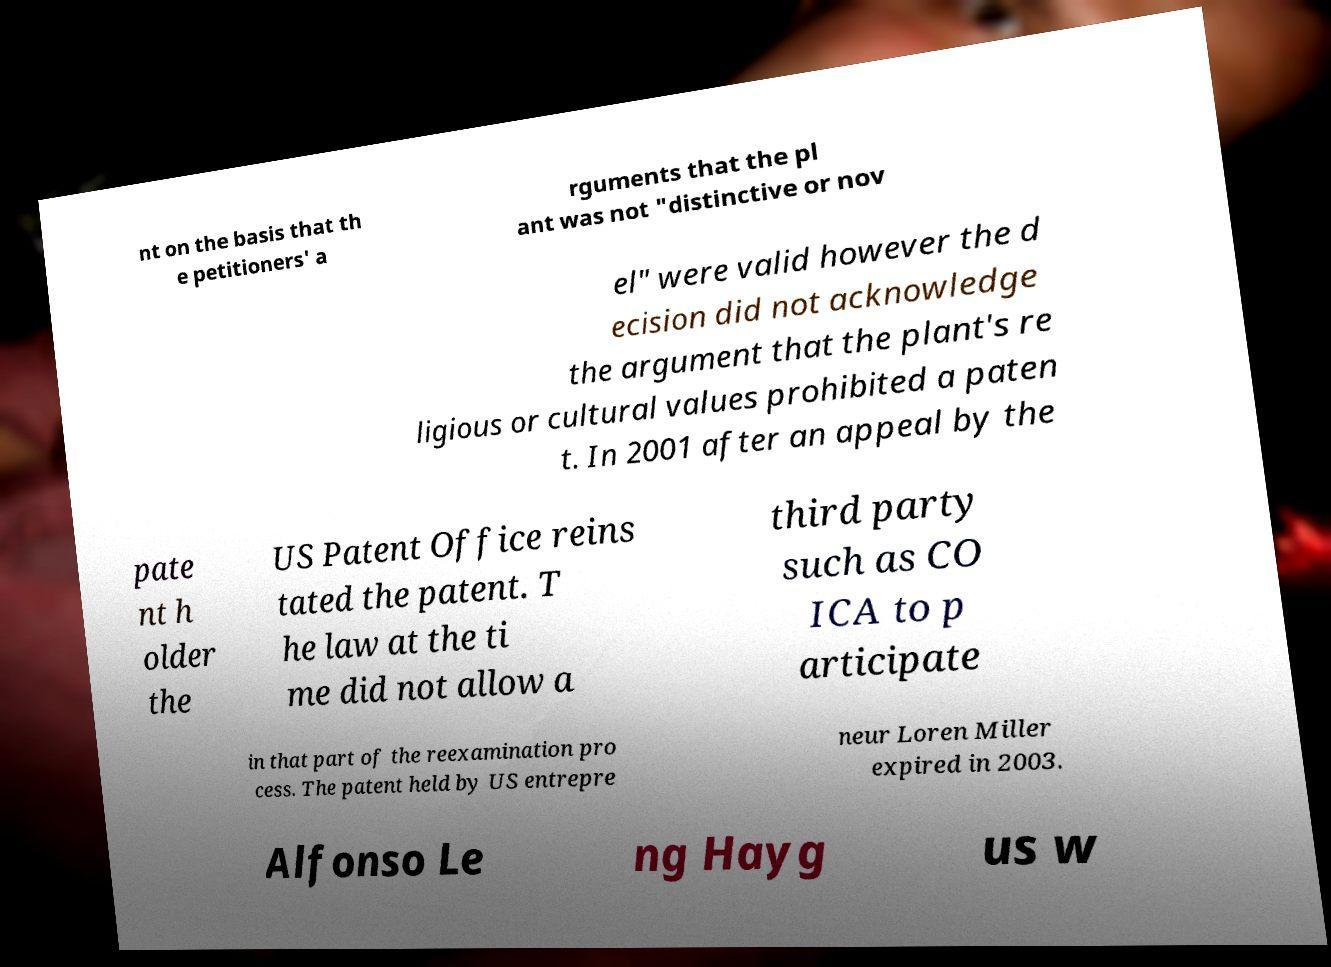For documentation purposes, I need the text within this image transcribed. Could you provide that? nt on the basis that th e petitioners' a rguments that the pl ant was not "distinctive or nov el" were valid however the d ecision did not acknowledge the argument that the plant's re ligious or cultural values prohibited a paten t. In 2001 after an appeal by the pate nt h older the US Patent Office reins tated the patent. T he law at the ti me did not allow a third party such as CO ICA to p articipate in that part of the reexamination pro cess. The patent held by US entrepre neur Loren Miller expired in 2003. Alfonso Le ng Hayg us w 